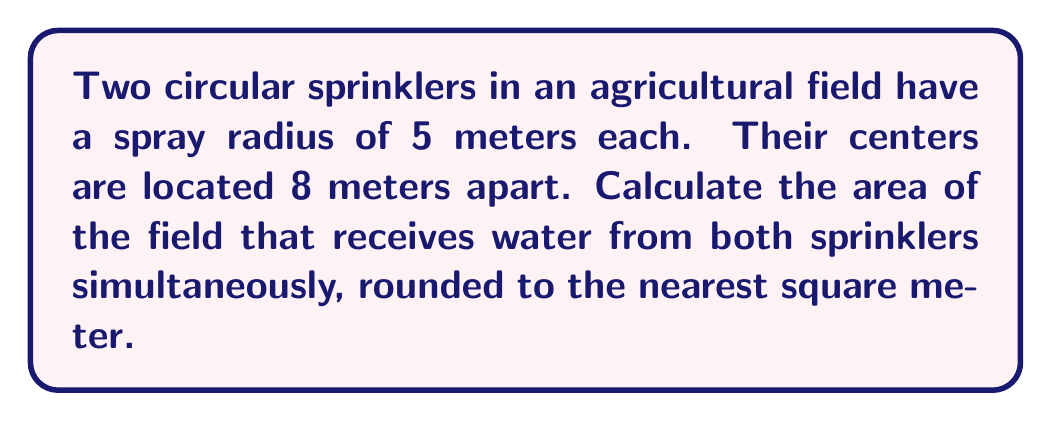Can you solve this math problem? Let's approach this step-by-step:

1) This problem involves finding the area of intersection between two circles. The formula for this area is:

   $$A = 2r^2 \arccos(\frac{d}{2r}) - d\sqrt{r^2 - \frac{d^2}{4}}$$

   where $r$ is the radius of each circle and $d$ is the distance between their centers.

2) We're given:
   $r = 5$ meters
   $d = 8$ meters

3) Let's substitute these values into our formula:

   $$A = 2(5^2) \arccos(\frac{8}{2(5)}) - 8\sqrt{5^2 - \frac{8^2}{4}}$$

4) Simplify inside the arccos and under the square root:

   $$A = 50 \arccos(\frac{4}{5}) - 8\sqrt{25 - 16}$$

5) Evaluate:
   
   $$A = 50 \arccos(0.8) - 8\sqrt{9}$$
   
   $$A = 50(0.6435) - 8(3)$$
   
   $$A = 32.175 - 24$$
   
   $$A = 8.175$$

6) Rounding to the nearest square meter:

   $$A \approx 8\text{ m}^2$$

[asy]
import geometry;

unitsize(10mm);

pair O1 = (0,0), O2 = (8,0);
real r = 5;

draw(circle(O1,r));
draw(circle(O2,r));

draw(O1--O2,dashed);

label("5m",O1-(r,0),W);
label("5m",O2+(r,0),E);
label("8m",(4,0),S);

dot("O1",O1,NW);
dot("O2",O2,NE);

path p = buildcycle(arc(O1,r,0,180), arc(O2,r,180,0));
fill(p,lightgray);
[/asy]
Answer: 8 m² 